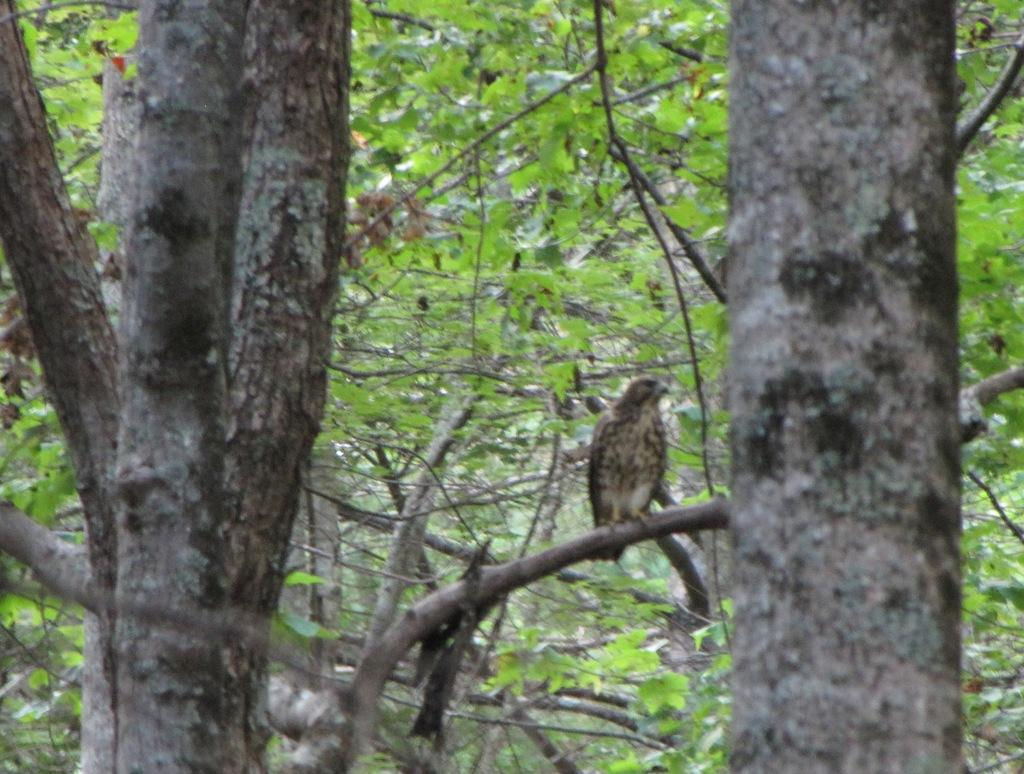What type of vegetation can be seen in the image? There are trees in the image. Can you describe any animals present in the image? There is a bird on a branch in the image. Where is the volleyball court located in the image? There is no volleyball court present in the image. What type of milk is being served to the bird in the image? There is no milk or servant present in the image; it only features trees and a bird on a branch. 